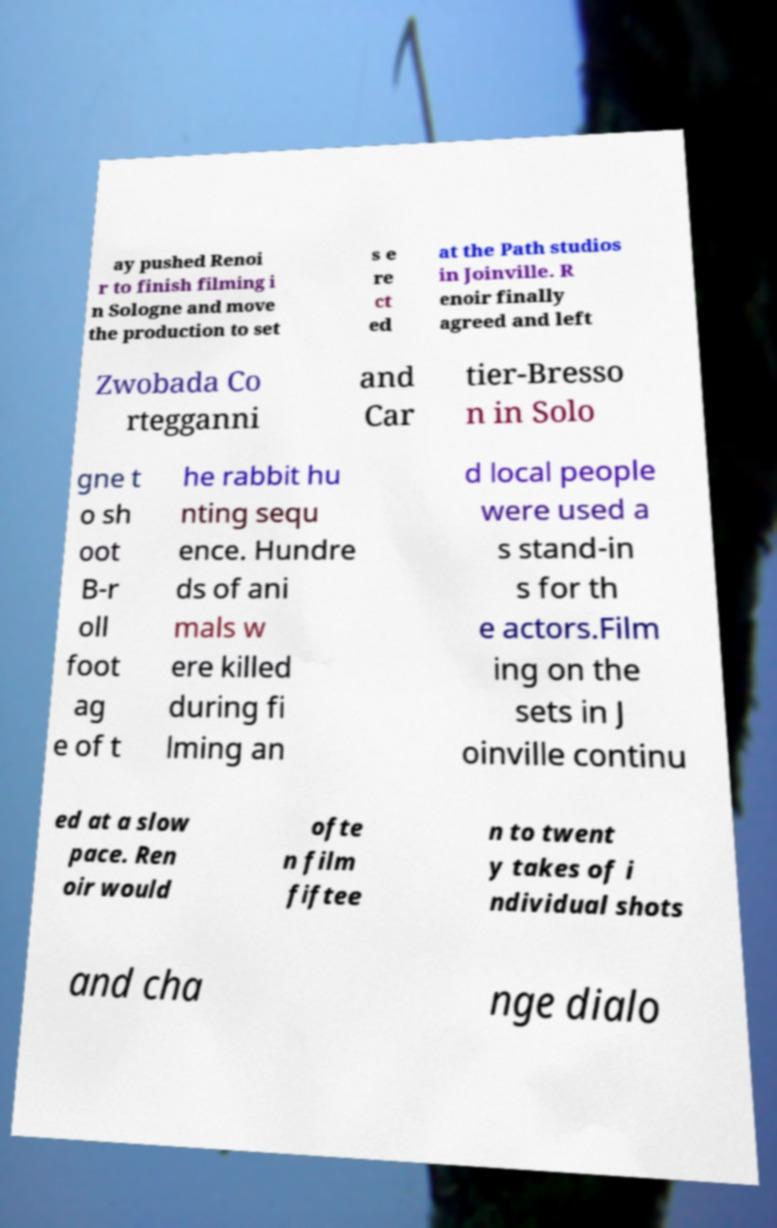Please identify and transcribe the text found in this image. ay pushed Renoi r to finish filming i n Sologne and move the production to set s e re ct ed at the Path studios in Joinville. R enoir finally agreed and left Zwobada Co rtegganni and Car tier-Bresso n in Solo gne t o sh oot B-r oll foot ag e of t he rabbit hu nting sequ ence. Hundre ds of ani mals w ere killed during fi lming an d local people were used a s stand-in s for th e actors.Film ing on the sets in J oinville continu ed at a slow pace. Ren oir would ofte n film fiftee n to twent y takes of i ndividual shots and cha nge dialo 